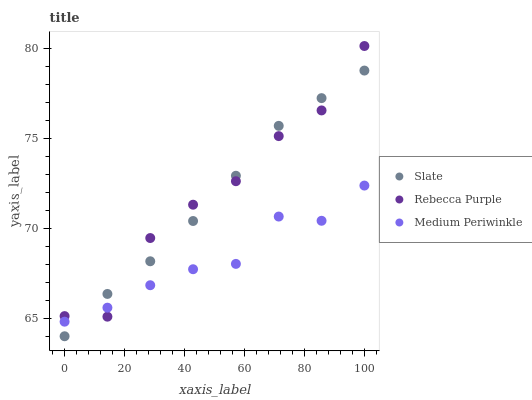Does Medium Periwinkle have the minimum area under the curve?
Answer yes or no. Yes. Does Rebecca Purple have the maximum area under the curve?
Answer yes or no. Yes. Does Rebecca Purple have the minimum area under the curve?
Answer yes or no. No. Does Medium Periwinkle have the maximum area under the curve?
Answer yes or no. No. Is Slate the smoothest?
Answer yes or no. Yes. Is Rebecca Purple the roughest?
Answer yes or no. Yes. Is Medium Periwinkle the smoothest?
Answer yes or no. No. Is Medium Periwinkle the roughest?
Answer yes or no. No. Does Slate have the lowest value?
Answer yes or no. Yes. Does Medium Periwinkle have the lowest value?
Answer yes or no. No. Does Rebecca Purple have the highest value?
Answer yes or no. Yes. Does Medium Periwinkle have the highest value?
Answer yes or no. No. Does Rebecca Purple intersect Slate?
Answer yes or no. Yes. Is Rebecca Purple less than Slate?
Answer yes or no. No. Is Rebecca Purple greater than Slate?
Answer yes or no. No. 